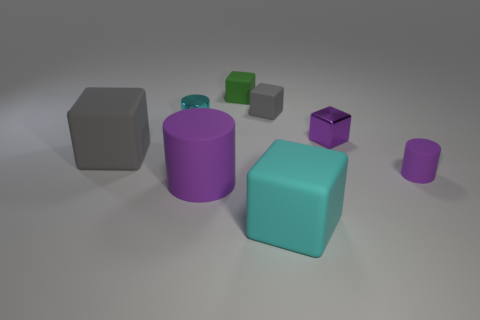Subtract 3 blocks. How many blocks are left? 2 Subtract all cyan cubes. How many cubes are left? 4 Subtract all cyan cubes. How many cubes are left? 4 Subtract all blue blocks. Subtract all cyan balls. How many blocks are left? 5 Add 2 large cylinders. How many objects exist? 10 Subtract all cylinders. How many objects are left? 5 Subtract all tiny gray metal cylinders. Subtract all cubes. How many objects are left? 3 Add 6 small green blocks. How many small green blocks are left? 7 Add 1 big cyan matte cubes. How many big cyan matte cubes exist? 2 Subtract 1 purple blocks. How many objects are left? 7 